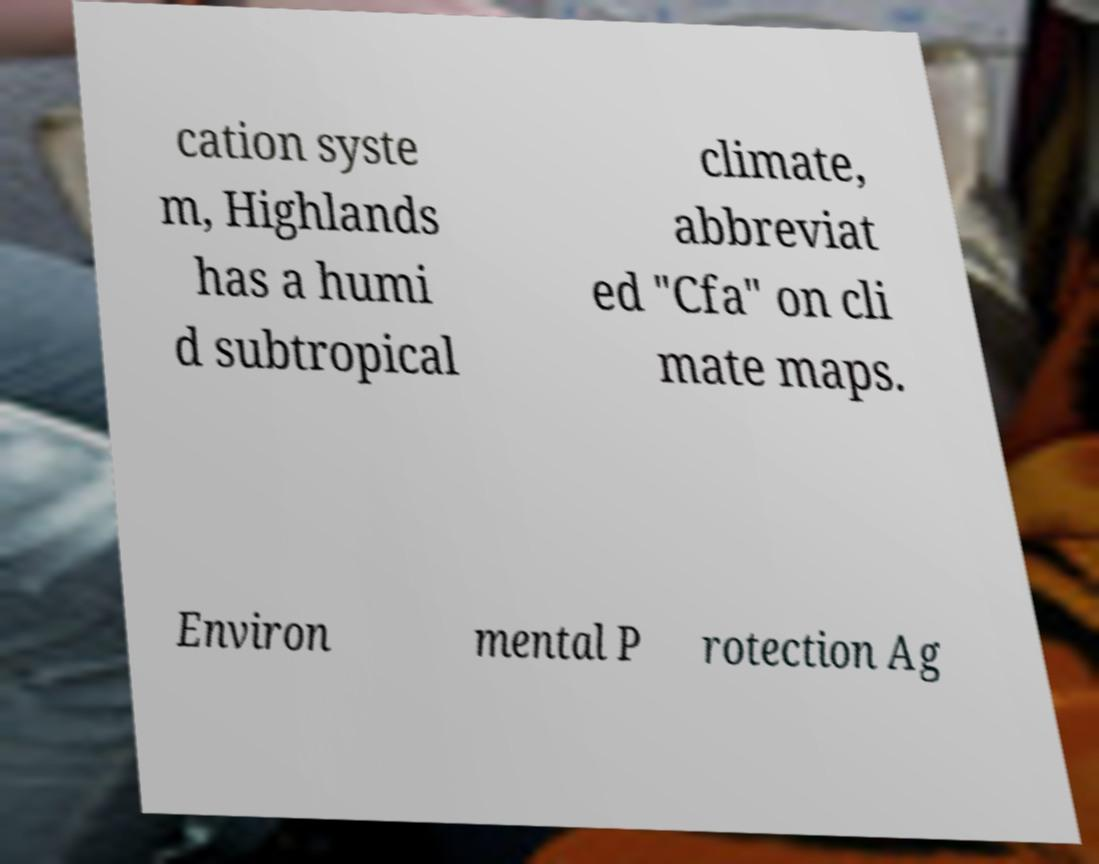Could you extract and type out the text from this image? cation syste m, Highlands has a humi d subtropical climate, abbreviat ed "Cfa" on cli mate maps. Environ mental P rotection Ag 